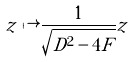Convert formula to latex. <formula><loc_0><loc_0><loc_500><loc_500>z \mapsto \frac { 1 } { \sqrt { D ^ { 2 } - 4 F } } z</formula> 